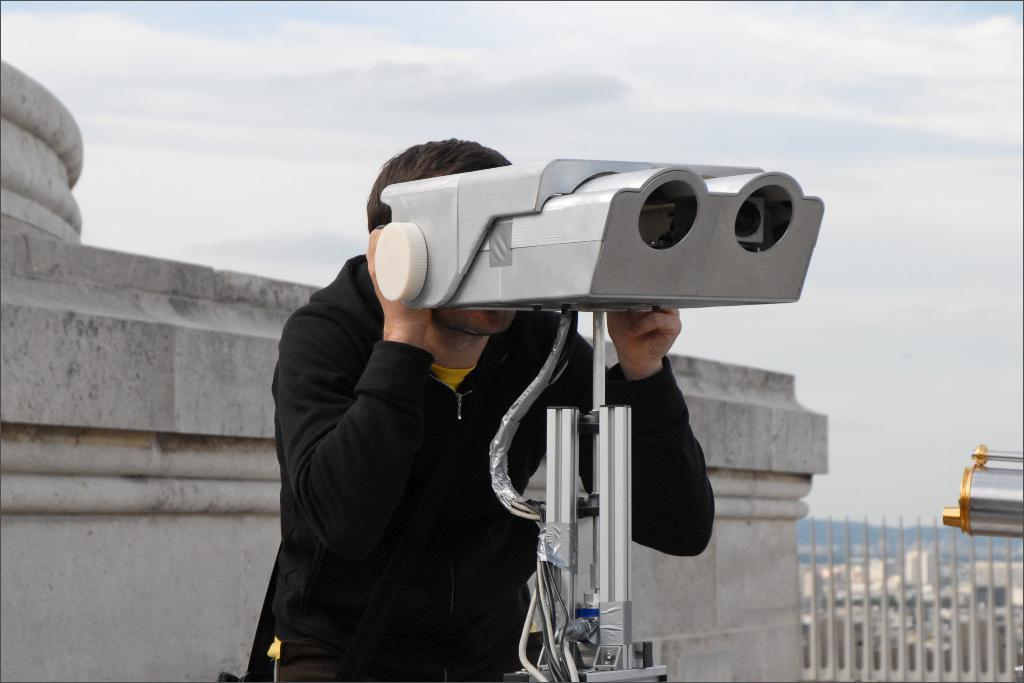What is the main subject in the foreground of the image? There is a person in the foreground of the image. What is the person holding in their hand? The person is holding an object in their hand. What can be seen in the background of the image? There is a fence, a building, trees, and the sky visible in the background of the image. Can you describe the time of day when the image was likely taken? The image was likely taken during the day, as the sky is visible and not dark. What type of current is flowing through the rings in the image? There are no rings present in the image, so there is no current flowing through them. 